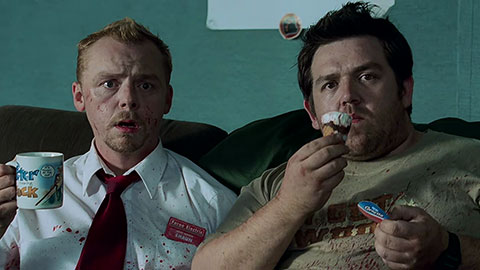If these characters were superheroes, what powers would they have? If Shaun and Ed were superheroes, Shaun would likely have quick reflexes and strategic planning abilities, allowing him to navigate and survive chaotic situations effectively. Given his role as a leader and problem-solver, he might also possess enhanced strength and endurance to fend off zombies. Ed, on the other hand, would probably have comedic and morale-boosting powers, using humor and light-heartedness to keep spirits up in dire situations. He might also have an uncanny ability to find food and comforts in the most unlikely places, ensuring they never lack sustenance. 